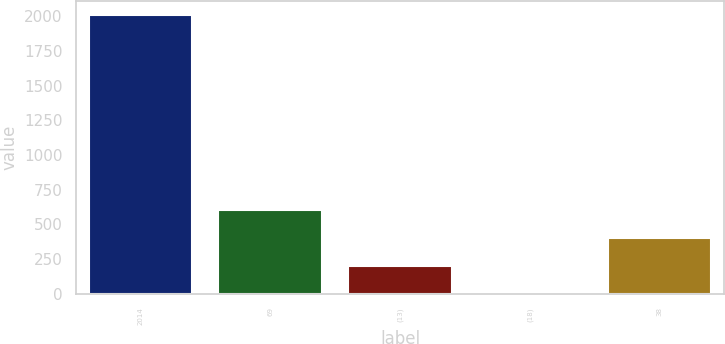<chart> <loc_0><loc_0><loc_500><loc_500><bar_chart><fcel>2014<fcel>69<fcel>(13)<fcel>(18)<fcel>38<nl><fcel>2013<fcel>606<fcel>204<fcel>3<fcel>405<nl></chart> 